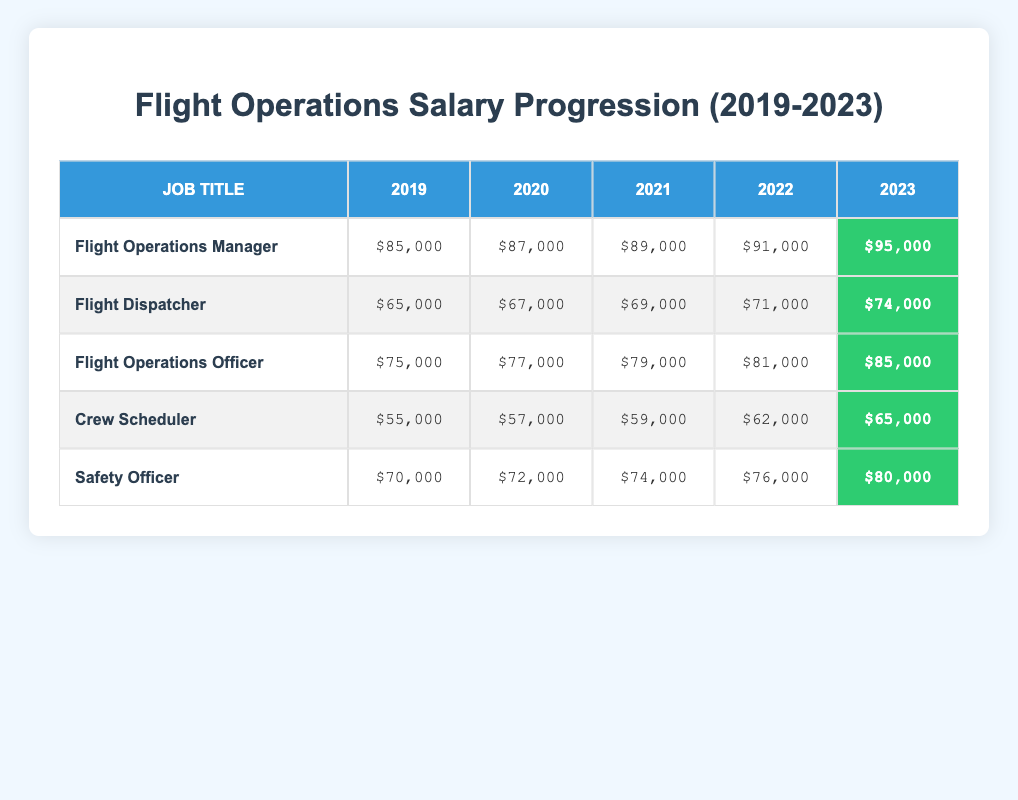What was the salary of the Flight Operations Manager in 2021? The table shows the salary for the Flight Operations Manager in the year 2021 as $89,000.
Answer: $89,000 What is the difference in salary for the Flight Dispatcher from 2019 to 2023? The salary for the Flight Dispatcher in 2019 was $65,000, and in 2023 it is $74,000. The difference is $74,000 - $65,000 = $9,000.
Answer: $9,000 Is the salary of the Safety Officer higher than that of the Crew Scheduler in 2022? The salary of the Safety Officer in 2022 was $76,000, while the Crew Scheduler's salary was $62,000. Since $76,000 is greater than $62,000, the answer is yes.
Answer: Yes What is the average salary of all positions in 2023? To find the average, we sum the salaries for each position in 2023: $95,000 + $74,000 + $85,000 + $65,000 + $80,000 = $399,000. There are 5 positions, so the average is $399,000 / 5 = $79,800.
Answer: $79,800 Has the salary for Flight Operations Officer increased every year from 2019 to 2023? The table shows the salaries: $75,000 in 2019, $77,000 in 2020, $79,000 in 2021, $81,000 in 2022, and $85,000 in 2023. Each year shows an increase compared to the previous year, so the statement is true.
Answer: Yes What was the median salary of all positions in 2020? The salaries for 2020 are: $87,000 (Flight Operations Manager), $67,000 (Flight Dispatcher), $77,000 (Flight Operations Officer), $57,000 (Crew Scheduler), and $72,000 (Safety Officer). Arranging these in order: $57,000; $67,000; $72,000; $77,000; $87,000. The median (middle value) is $72,000.
Answer: $72,000 Which position had the highest salary increase over the five years? Calculating the difference in salary from 2019 to 2023 for each position: Flight Operations Manager: $10,000; Flight Dispatcher: $9,000; Flight Operations Officer: $10,000; Crew Scheduler: $10,000; Safety Officer: $10,000. The highest increase is tied at $10,000 for multiple positions.
Answer: Flight Operations Manager, Flight Operations Officer, Crew Scheduler, Safety Officer What was the salary trend for Crew Scheduler from 2019 to 2023? The Crew Scheduler's salary showed this progression: $55,000 in 2019, $57,000 in 2020, $59,000 in 2021, $62,000 in 2022, and $65,000 in 2023. This indicates a consistent increase each year.
Answer: Increasing Did the Flight Operations Manager's salary surpass $90,000 in 2022? In 2022, the salary of the Flight Operations Manager was $91,000. Since $91,000 is greater than $90,000, the answer is yes.
Answer: Yes 